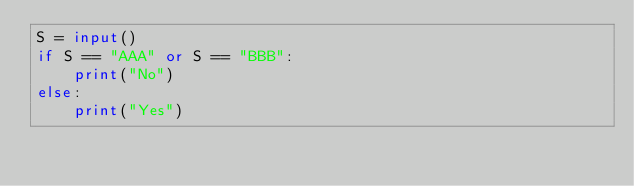<code> <loc_0><loc_0><loc_500><loc_500><_Python_>S = input()
if S == "AAA" or S == "BBB":
    print("No")
else:
    print("Yes")
</code> 